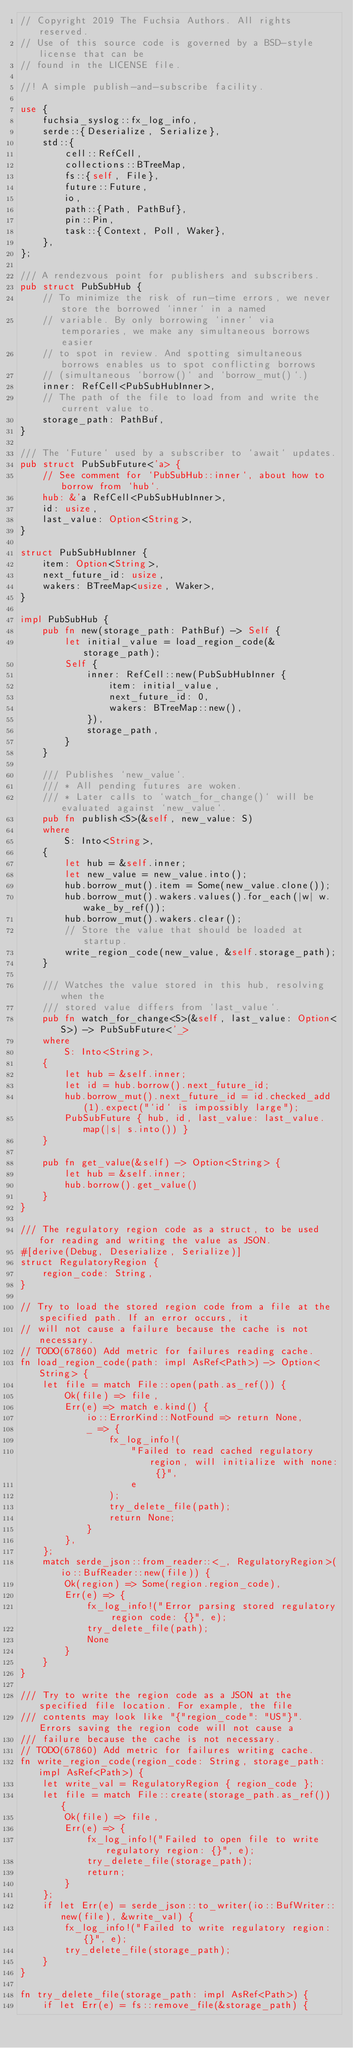<code> <loc_0><loc_0><loc_500><loc_500><_Rust_>// Copyright 2019 The Fuchsia Authors. All rights reserved.
// Use of this source code is governed by a BSD-style license that can be
// found in the LICENSE file.

//! A simple publish-and-subscribe facility.

use {
    fuchsia_syslog::fx_log_info,
    serde::{Deserialize, Serialize},
    std::{
        cell::RefCell,
        collections::BTreeMap,
        fs::{self, File},
        future::Future,
        io,
        path::{Path, PathBuf},
        pin::Pin,
        task::{Context, Poll, Waker},
    },
};

/// A rendezvous point for publishers and subscribers.
pub struct PubSubHub {
    // To minimize the risk of run-time errors, we never store the borrowed `inner` in a named
    // variable. By only borrowing `inner` via temporaries, we make any simultaneous borrows easier
    // to spot in review. And spotting simultaneous borrows enables us to spot conflicting borrows
    // (simultaneous `borrow()` and `borrow_mut()`.)
    inner: RefCell<PubSubHubInner>,
    // The path of the file to load from and write the current value to.
    storage_path: PathBuf,
}

/// The `Future` used by a subscriber to `await` updates.
pub struct PubSubFuture<'a> {
    // See comment for `PubSubHub::inner`, about how to borrow from `hub`.
    hub: &'a RefCell<PubSubHubInner>,
    id: usize,
    last_value: Option<String>,
}

struct PubSubHubInner {
    item: Option<String>,
    next_future_id: usize,
    wakers: BTreeMap<usize, Waker>,
}

impl PubSubHub {
    pub fn new(storage_path: PathBuf) -> Self {
        let initial_value = load_region_code(&storage_path);
        Self {
            inner: RefCell::new(PubSubHubInner {
                item: initial_value,
                next_future_id: 0,
                wakers: BTreeMap::new(),
            }),
            storage_path,
        }
    }

    /// Publishes `new_value`.
    /// * All pending futures are woken.
    /// * Later calls to `watch_for_change()` will be evaluated against `new_value`.
    pub fn publish<S>(&self, new_value: S)
    where
        S: Into<String>,
    {
        let hub = &self.inner;
        let new_value = new_value.into();
        hub.borrow_mut().item = Some(new_value.clone());
        hub.borrow_mut().wakers.values().for_each(|w| w.wake_by_ref());
        hub.borrow_mut().wakers.clear();
        // Store the value that should be loaded at startup.
        write_region_code(new_value, &self.storage_path);
    }

    /// Watches the value stored in this hub, resolving when the
    /// stored value differs from `last_value`.
    pub fn watch_for_change<S>(&self, last_value: Option<S>) -> PubSubFuture<'_>
    where
        S: Into<String>,
    {
        let hub = &self.inner;
        let id = hub.borrow().next_future_id;
        hub.borrow_mut().next_future_id = id.checked_add(1).expect("`id` is impossibly large");
        PubSubFuture { hub, id, last_value: last_value.map(|s| s.into()) }
    }

    pub fn get_value(&self) -> Option<String> {
        let hub = &self.inner;
        hub.borrow().get_value()
    }
}

/// The regulatory region code as a struct, to be used for reading and writing the value as JSON.
#[derive(Debug, Deserialize, Serialize)]
struct RegulatoryRegion {
    region_code: String,
}

// Try to load the stored region code from a file at the specified path. If an error occurs, it
// will not cause a failure because the cache is not necessary.
// TODO(67860) Add metric for failures reading cache.
fn load_region_code(path: impl AsRef<Path>) -> Option<String> {
    let file = match File::open(path.as_ref()) {
        Ok(file) => file,
        Err(e) => match e.kind() {
            io::ErrorKind::NotFound => return None,
            _ => {
                fx_log_info!(
                    "Failed to read cached regulatory region, will initialize with none: {}",
                    e
                );
                try_delete_file(path);
                return None;
            }
        },
    };
    match serde_json::from_reader::<_, RegulatoryRegion>(io::BufReader::new(file)) {
        Ok(region) => Some(region.region_code),
        Err(e) => {
            fx_log_info!("Error parsing stored regulatory region code: {}", e);
            try_delete_file(path);
            None
        }
    }
}

/// Try to write the region code as a JSON at the specified file location. For example, the file
/// contents may look like "{"region_code": "US"}". Errors saving the region code will not cause a
/// failure because the cache is not necessary.
// TODO(67860) Add metric for failures writing cache.
fn write_region_code(region_code: String, storage_path: impl AsRef<Path>) {
    let write_val = RegulatoryRegion { region_code };
    let file = match File::create(storage_path.as_ref()) {
        Ok(file) => file,
        Err(e) => {
            fx_log_info!("Failed to open file to write regulatory region: {}", e);
            try_delete_file(storage_path);
            return;
        }
    };
    if let Err(e) = serde_json::to_writer(io::BufWriter::new(file), &write_val) {
        fx_log_info!("Failed to write regulatory region: {}", e);
        try_delete_file(storage_path);
    }
}

fn try_delete_file(storage_path: impl AsRef<Path>) {
    if let Err(e) = fs::remove_file(&storage_path) {</code> 